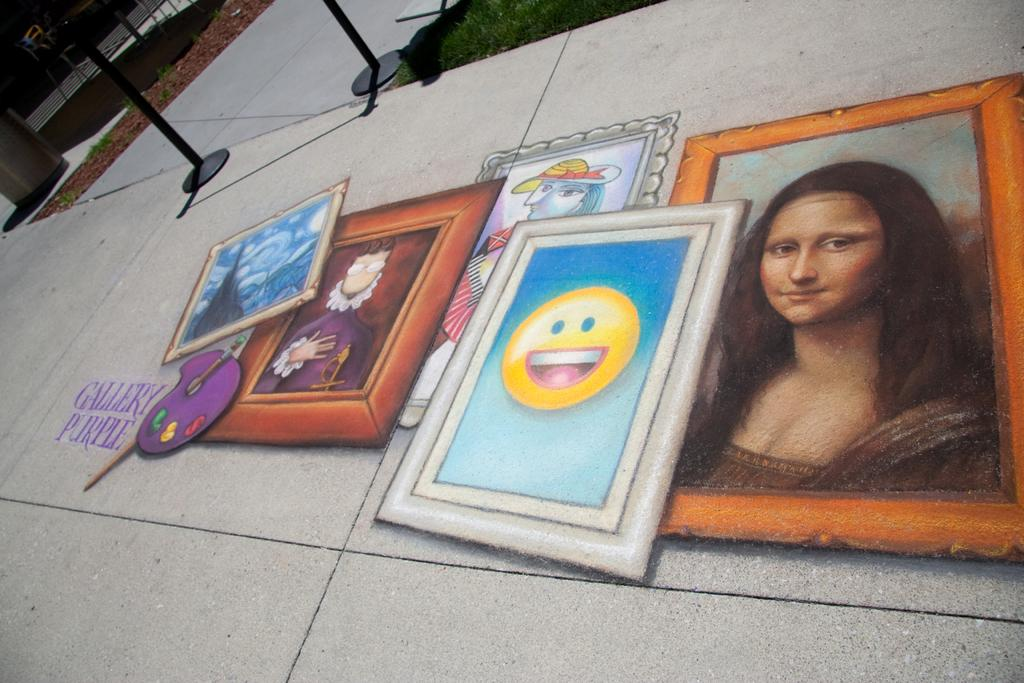What is on the floor in the image? There are photos on the floor in the image. What type of natural environment can be seen in the image? There is grass visible in the image. What else can be seen in the image besides the grass? There are objects in the image. What type of wound can be seen on the oranges in the image? There are no oranges or wounds present in the image; it features photos on the floor and grass. 